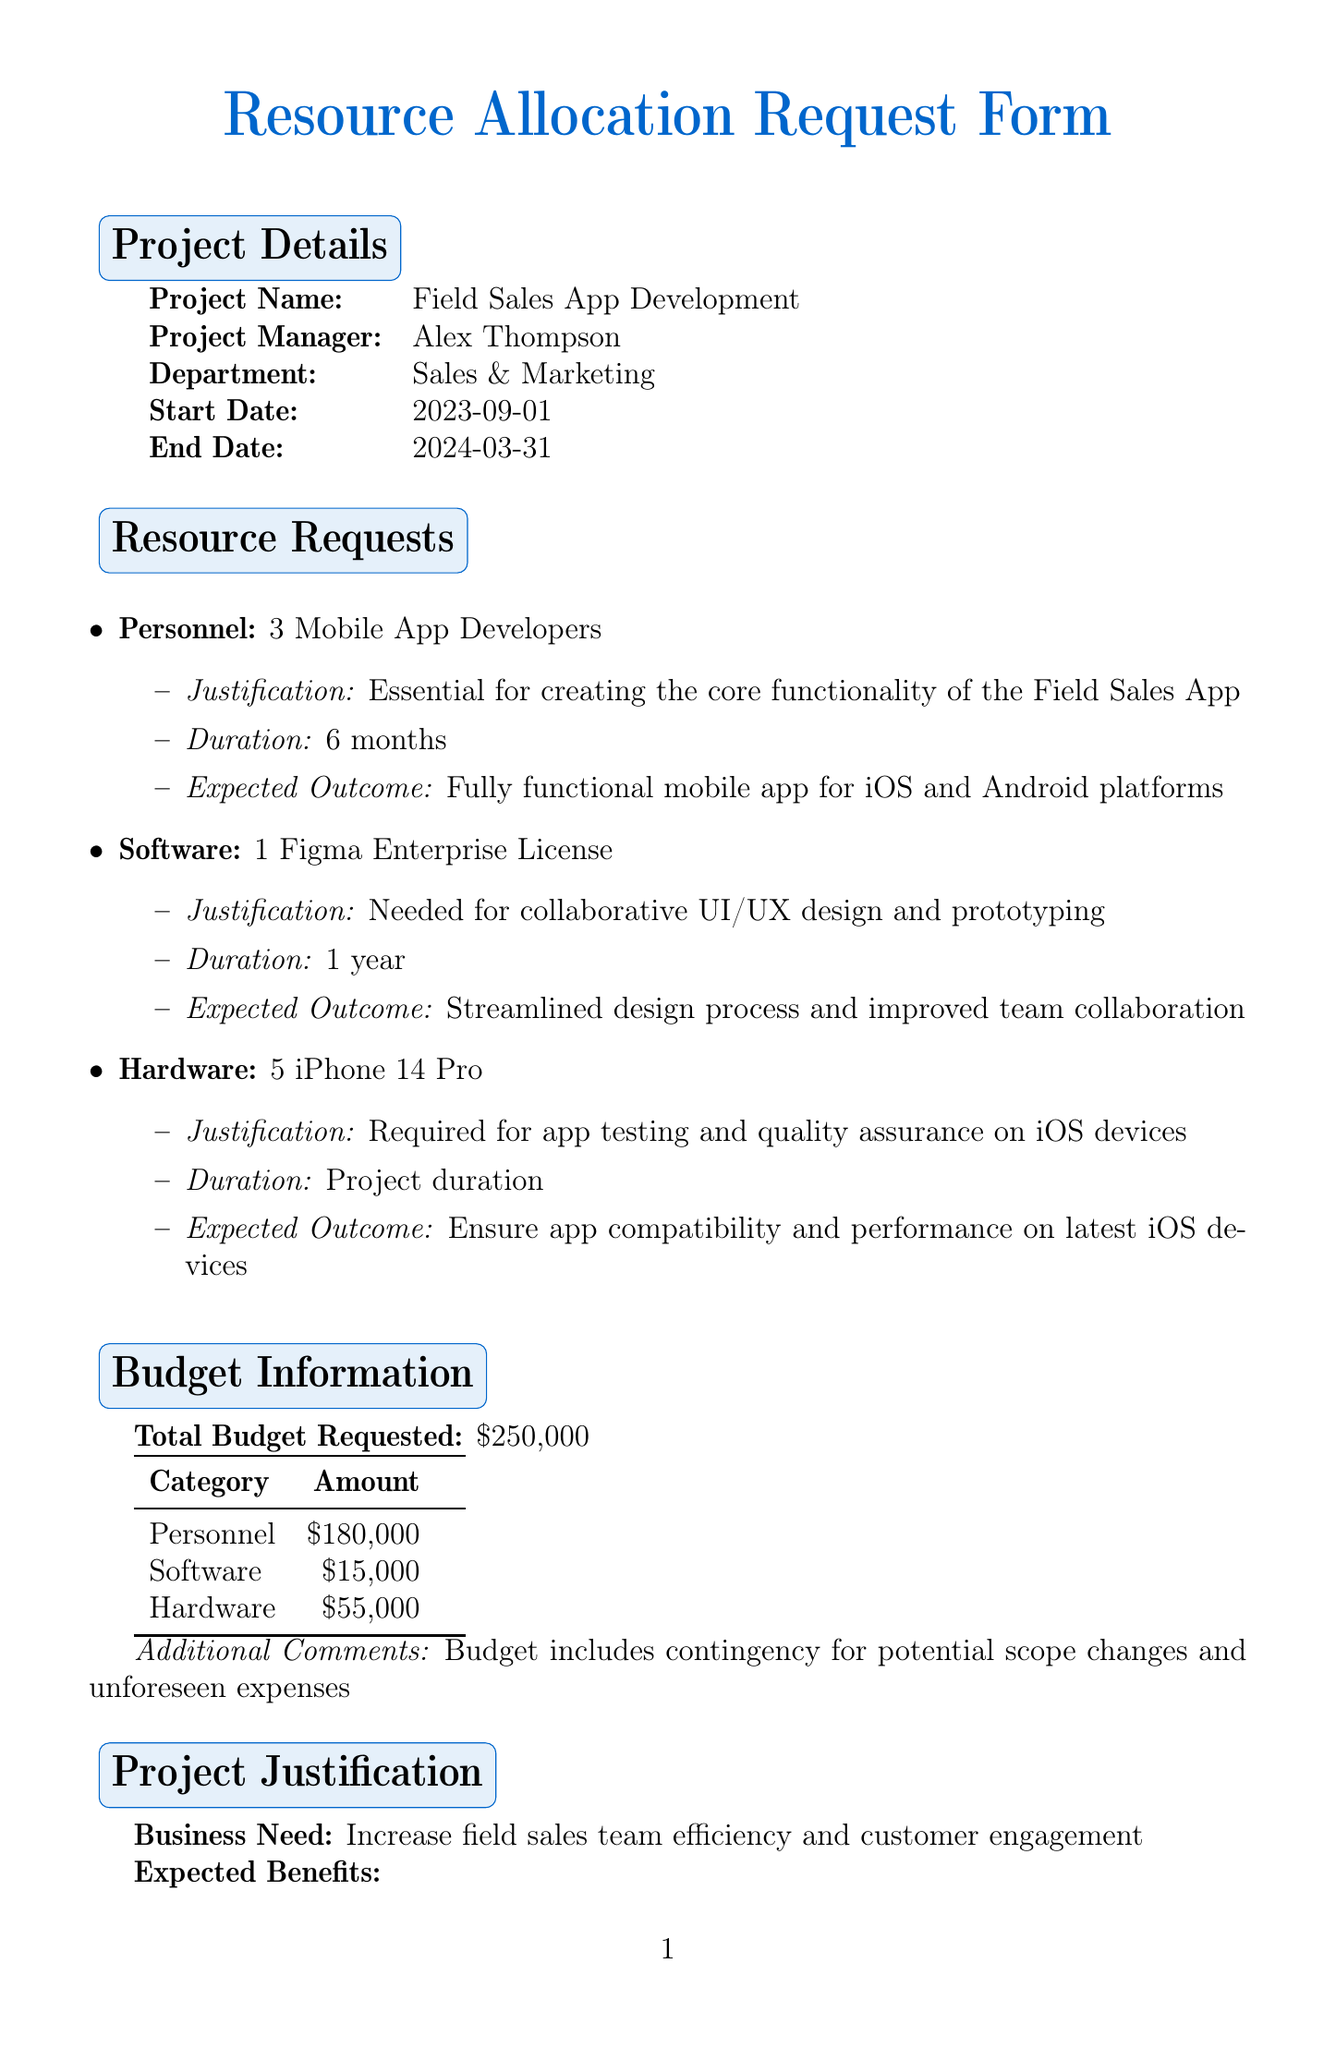what is the project name? The project name is listed in the project details section of the document, which states "Field Sales App Development."
Answer: Field Sales App Development who is the project manager? The project manager's name is provided in the project details section, which is "Alex Thompson."
Answer: Alex Thompson how many mobile app developers are requested? The document specifies a request for 3 mobile app developers in the resource requests section.
Answer: 3 what is the total budget requested? The total budget requested is clearly stated in the budget information section as $250,000.
Answer: $250,000 what is the duration for the iPhone 14 Pro hardware request? The duration for the iPhone 14 Pro request is noted in the document as "Project duration."
Answer: Project duration what are the expected benefits in terms of sales conversion rate? The expected benefit regarding sales conversion rates is detailed in the project justification section, indicating a 20% increase.
Answer: 20% what is the potential risk associated with resource allocation delay? The document lists a potential risk that relates to "Delay in resource allocation may impact project timeline."
Answer: Delay in resource allocation may impact project timeline what kind of feedback mechanism is mentioned? The communication plan mentions the use of "Regular team surveys and open discussion forums" for feedback.
Answer: Regular team surveys and open discussion forums who is the finance manager? The document lists the finance manager's name as "Michael Chen" in the approval section.
Answer: Michael Chen 